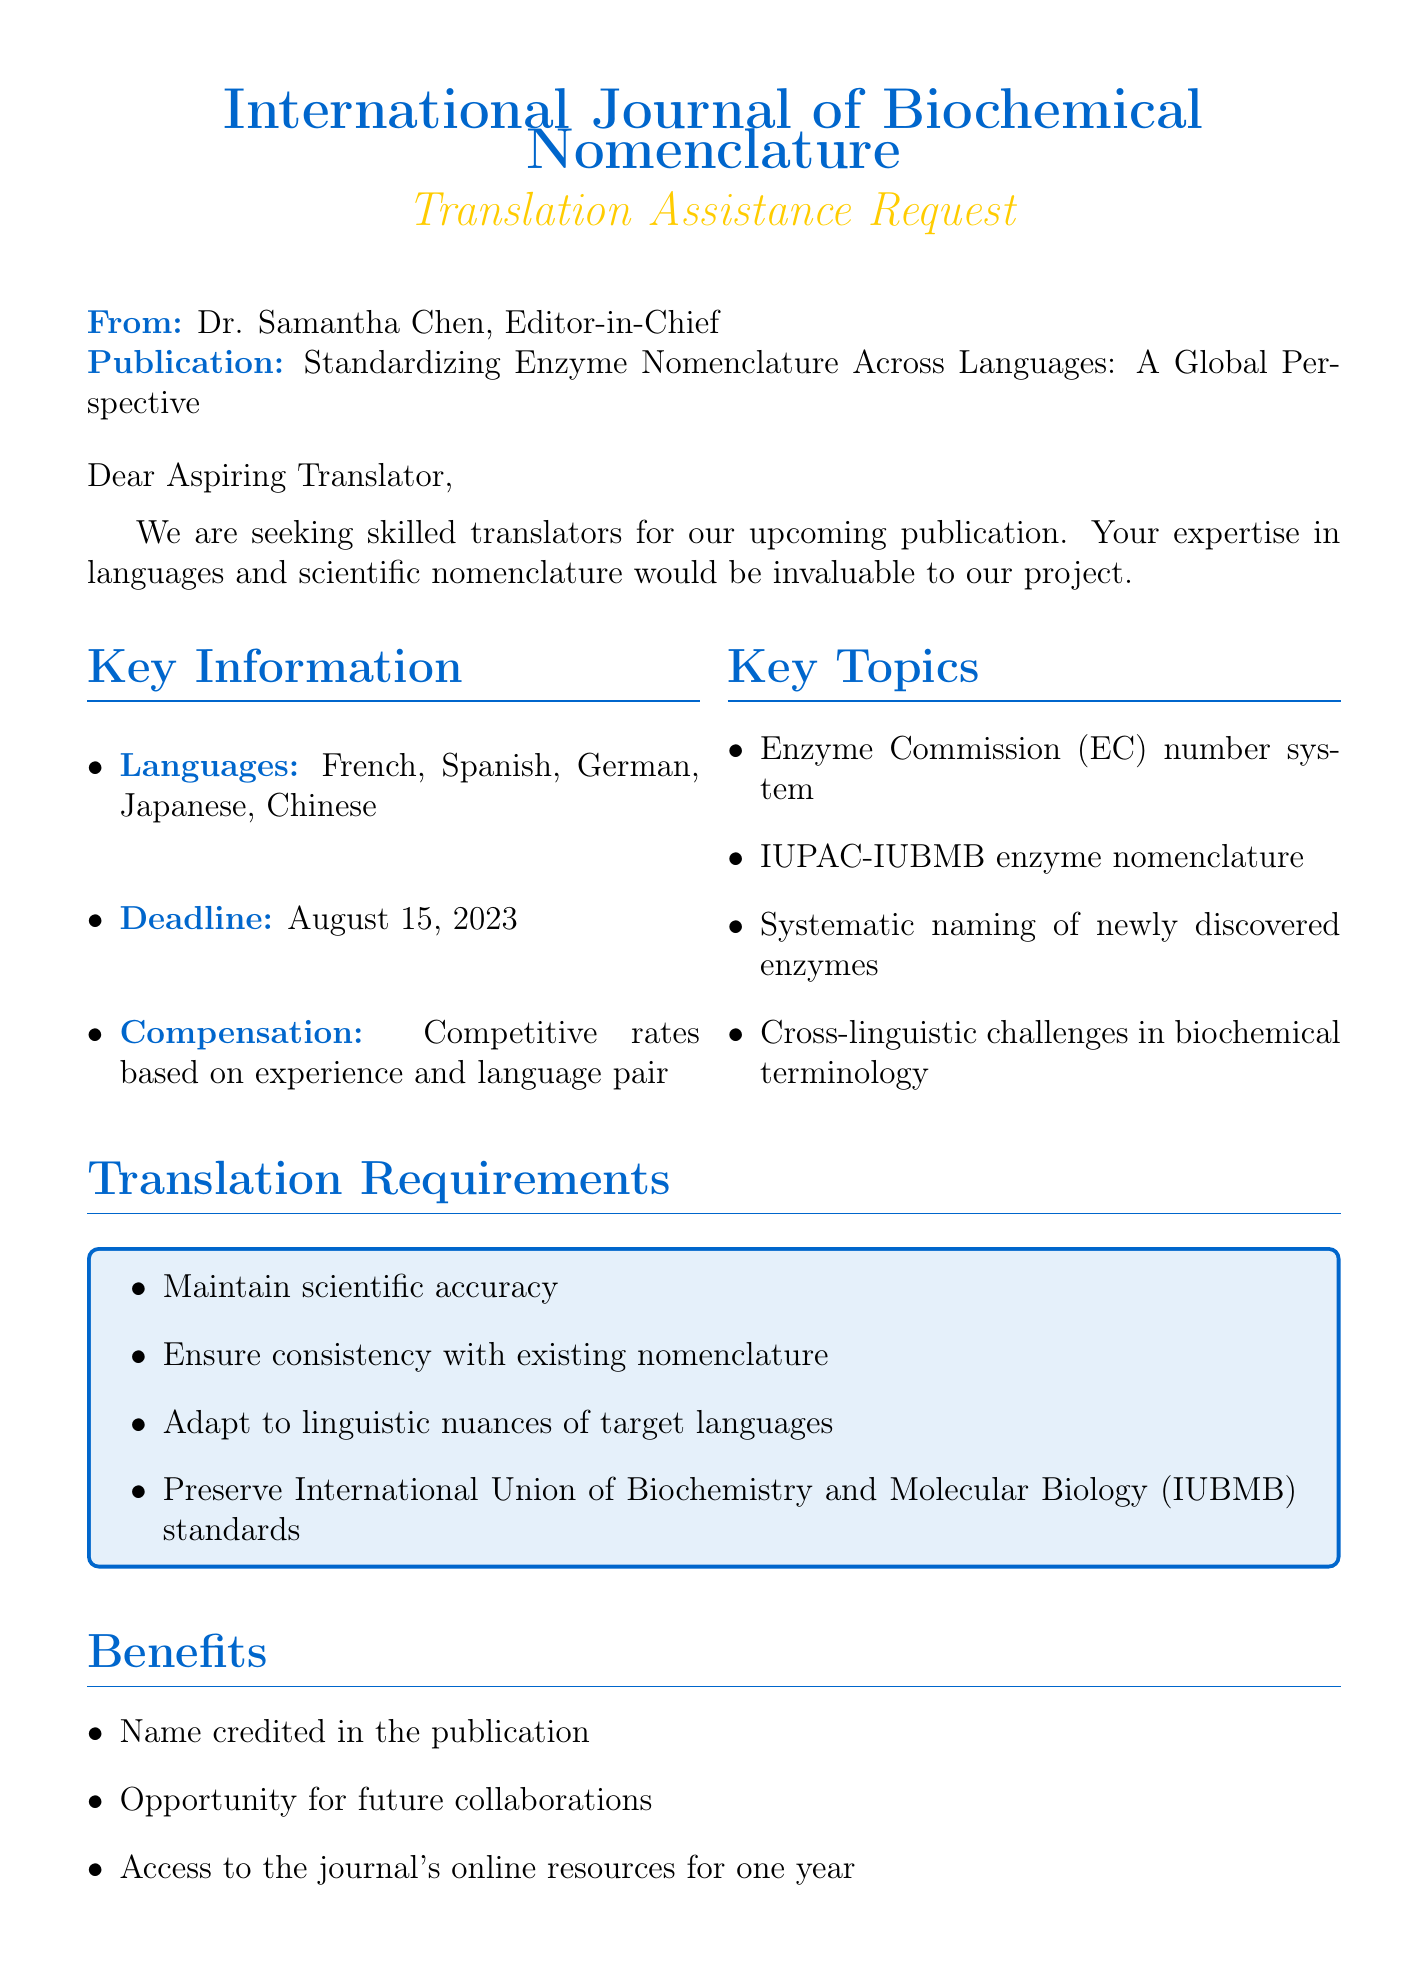What is the name of the journal? The document states that it is the "International Journal of Biochemical Nomenclature."
Answer: International Journal of Biochemical Nomenclature Who is the Editor-in-Chief? The document mentions that Dr. Samantha Chen is the Editor-in-Chief.
Answer: Dr. Samantha Chen What is the publication title? The title of the upcoming publication is "Standardizing Enzyme Nomenclature Across Languages: A Global Perspective."
Answer: Standardizing Enzyme Nomenclature Across Languages: A Global Perspective When is the translation deadline? The document indicates that the deadline for translations is August 15, 2023.
Answer: August 15, 2023 Which languages are required for translation? The required languages for translation include French, Spanish, German, Japanese, and Chinese.
Answer: French, Spanish, German, Japanese, Chinese What are translators expected to maintain? Translators are expected to maintain scientific accuracy according to the document.
Answer: Scientific accuracy What benefits are provided to translators? The document lists benefits such as being credited in the publication and access to online resources for one year.
Answer: Name credited in the publication, access to the journal's online resources for one year What is the application process mention? The application process includes submitting a CV, providing samples, and completing a test translation.
Answer: Submit CV, provide samples, complete a test translation What type of publication is this request for? This request is for translation assistance for a scientific publication.
Answer: Scientific publication 